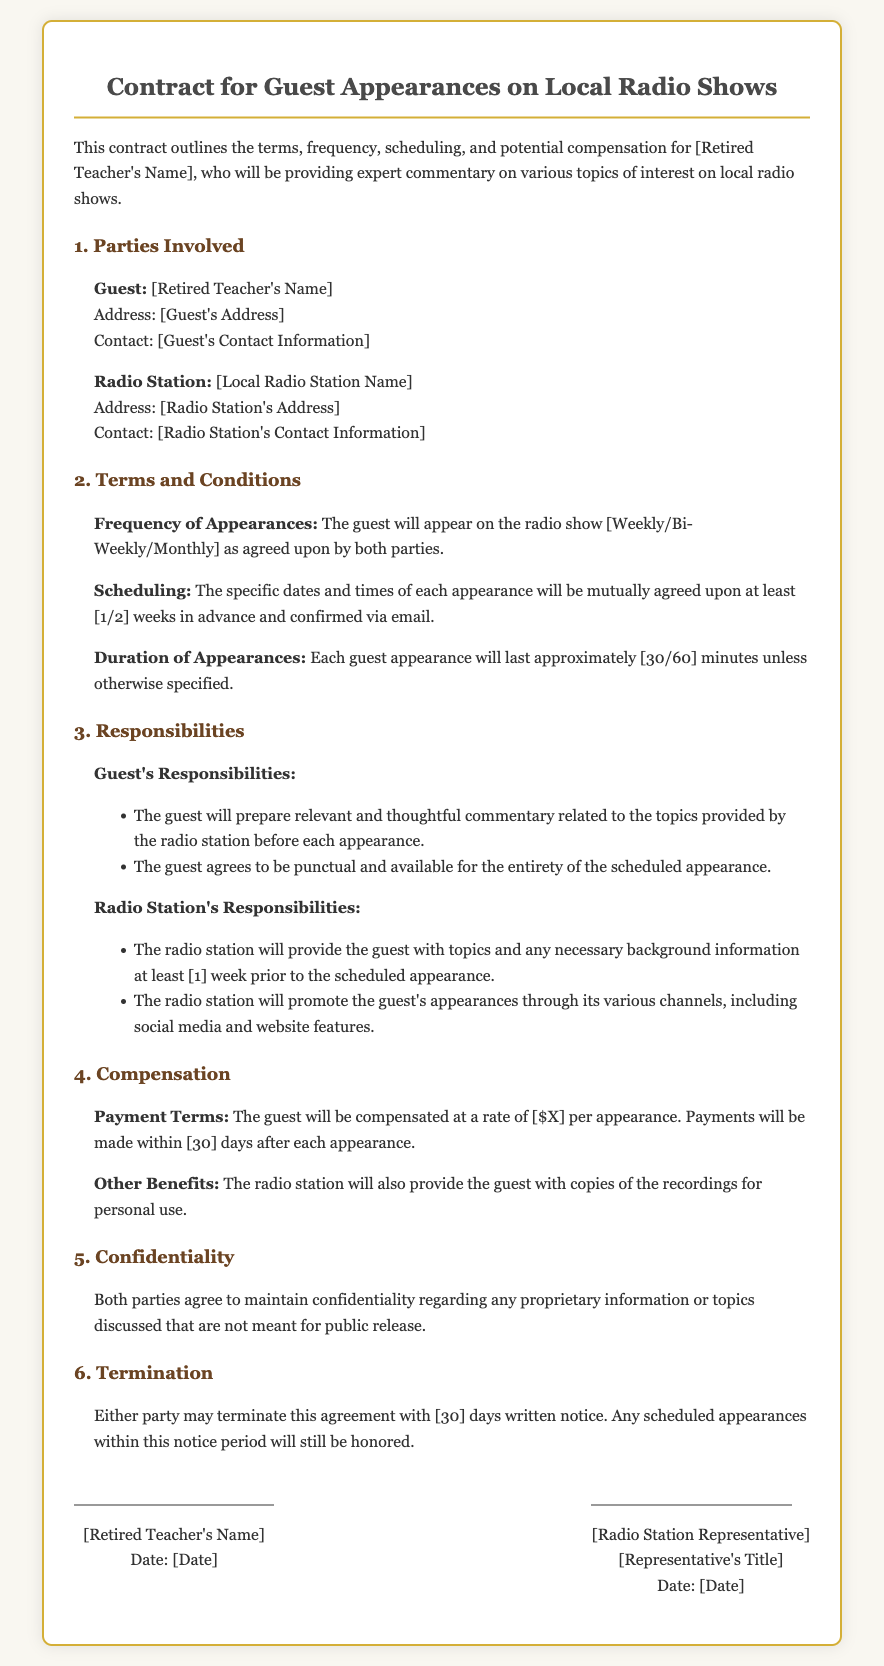What are the parties involved? The parties involved include the guest and the radio station, which are specifically named in the document.
Answer: Guest and Radio Station What is the frequency of appearances? The frequency of appearances is specified in the document as agreed upon by both parties.
Answer: Weekly/Bi-Weekly/Monthly What is the duration of each appearance? The document states that each guest appearance will last approximately either 30 or 60 minutes.
Answer: 30/60 minutes What are the payment terms? The document outlines that the guest will be compensated at a certain rate per appearance, alongside payment timing.
Answer: $X per appearance What is the notice period for termination? The document specifies that either party can terminate the agreement with a required notice period.
Answer: 30 days What responsibilities does the guest have? Guests are required to provide prepared and relevant commentary and to be punctual for appearances, as stated in the document.
Answer: Prepare commentary and be punctual What will the radio station provide the guest before appearances? The document indicates that the radio station will provide the guest with topics at least a week prior to the scheduled appearance.
Answer: Topics and background information Why must both parties maintain confidentiality? The document emphasizes confidentiality for proprietary information not meant for public release, which is a standard aspect of contracts.
Answer: Protect proprietary information Who signs the contract? The document specifies the signatories as the guest and the radio station representative, along with their titles and dates.
Answer: Guest and Radio Station Representative 